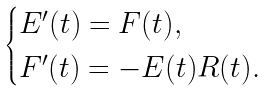<formula> <loc_0><loc_0><loc_500><loc_500>\begin{cases} E ^ { \prime } ( t ) = F ( t ) , \\ F ^ { \prime } ( t ) = - E ( t ) R ( t ) . \end{cases}</formula> 